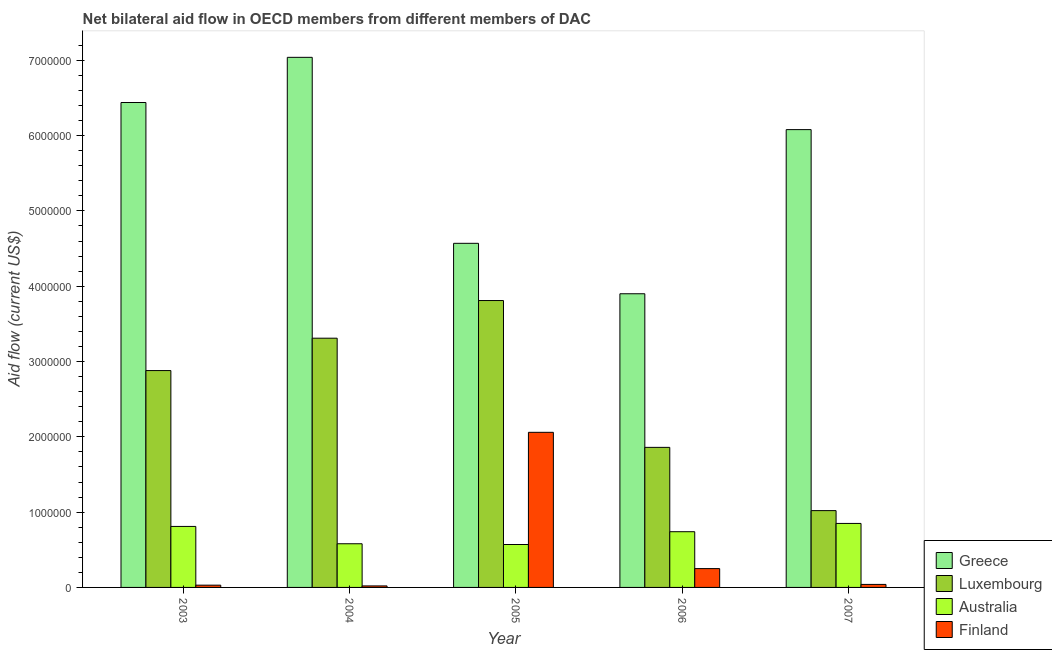How many different coloured bars are there?
Your response must be concise. 4. Are the number of bars on each tick of the X-axis equal?
Offer a very short reply. Yes. How many bars are there on the 1st tick from the right?
Give a very brief answer. 4. What is the amount of aid given by luxembourg in 2004?
Offer a very short reply. 3.31e+06. Across all years, what is the maximum amount of aid given by finland?
Make the answer very short. 2.06e+06. Across all years, what is the minimum amount of aid given by luxembourg?
Your answer should be very brief. 1.02e+06. In which year was the amount of aid given by australia minimum?
Your answer should be compact. 2005. What is the total amount of aid given by finland in the graph?
Ensure brevity in your answer.  2.40e+06. What is the difference between the amount of aid given by greece in 2003 and that in 2004?
Give a very brief answer. -6.00e+05. What is the difference between the amount of aid given by australia in 2005 and the amount of aid given by greece in 2007?
Keep it short and to the point. -2.80e+05. In how many years, is the amount of aid given by greece greater than 1400000 US$?
Offer a terse response. 5. What is the ratio of the amount of aid given by luxembourg in 2006 to that in 2007?
Provide a short and direct response. 1.82. Is the difference between the amount of aid given by finland in 2004 and 2006 greater than the difference between the amount of aid given by greece in 2004 and 2006?
Your answer should be very brief. No. What is the difference between the highest and the lowest amount of aid given by greece?
Your response must be concise. 3.14e+06. Is the sum of the amount of aid given by australia in 2003 and 2007 greater than the maximum amount of aid given by finland across all years?
Offer a very short reply. Yes. How many bars are there?
Provide a short and direct response. 20. How many years are there in the graph?
Keep it short and to the point. 5. Are the values on the major ticks of Y-axis written in scientific E-notation?
Offer a very short reply. No. Does the graph contain any zero values?
Give a very brief answer. No. Where does the legend appear in the graph?
Ensure brevity in your answer.  Bottom right. How many legend labels are there?
Your answer should be very brief. 4. What is the title of the graph?
Provide a succinct answer. Net bilateral aid flow in OECD members from different members of DAC. What is the label or title of the X-axis?
Your response must be concise. Year. What is the label or title of the Y-axis?
Your answer should be compact. Aid flow (current US$). What is the Aid flow (current US$) of Greece in 2003?
Your answer should be very brief. 6.44e+06. What is the Aid flow (current US$) in Luxembourg in 2003?
Give a very brief answer. 2.88e+06. What is the Aid flow (current US$) of Australia in 2003?
Your answer should be very brief. 8.10e+05. What is the Aid flow (current US$) in Finland in 2003?
Make the answer very short. 3.00e+04. What is the Aid flow (current US$) in Greece in 2004?
Your answer should be compact. 7.04e+06. What is the Aid flow (current US$) in Luxembourg in 2004?
Offer a very short reply. 3.31e+06. What is the Aid flow (current US$) in Australia in 2004?
Make the answer very short. 5.80e+05. What is the Aid flow (current US$) of Finland in 2004?
Your answer should be very brief. 2.00e+04. What is the Aid flow (current US$) in Greece in 2005?
Offer a terse response. 4.57e+06. What is the Aid flow (current US$) of Luxembourg in 2005?
Keep it short and to the point. 3.81e+06. What is the Aid flow (current US$) in Australia in 2005?
Offer a terse response. 5.70e+05. What is the Aid flow (current US$) in Finland in 2005?
Ensure brevity in your answer.  2.06e+06. What is the Aid flow (current US$) in Greece in 2006?
Your answer should be very brief. 3.90e+06. What is the Aid flow (current US$) in Luxembourg in 2006?
Offer a terse response. 1.86e+06. What is the Aid flow (current US$) in Australia in 2006?
Ensure brevity in your answer.  7.40e+05. What is the Aid flow (current US$) in Finland in 2006?
Provide a succinct answer. 2.50e+05. What is the Aid flow (current US$) of Greece in 2007?
Your response must be concise. 6.08e+06. What is the Aid flow (current US$) in Luxembourg in 2007?
Offer a very short reply. 1.02e+06. What is the Aid flow (current US$) in Australia in 2007?
Offer a terse response. 8.50e+05. Across all years, what is the maximum Aid flow (current US$) in Greece?
Your response must be concise. 7.04e+06. Across all years, what is the maximum Aid flow (current US$) of Luxembourg?
Your answer should be very brief. 3.81e+06. Across all years, what is the maximum Aid flow (current US$) of Australia?
Keep it short and to the point. 8.50e+05. Across all years, what is the maximum Aid flow (current US$) in Finland?
Your response must be concise. 2.06e+06. Across all years, what is the minimum Aid flow (current US$) of Greece?
Give a very brief answer. 3.90e+06. Across all years, what is the minimum Aid flow (current US$) of Luxembourg?
Offer a very short reply. 1.02e+06. Across all years, what is the minimum Aid flow (current US$) in Australia?
Your response must be concise. 5.70e+05. Across all years, what is the minimum Aid flow (current US$) in Finland?
Provide a succinct answer. 2.00e+04. What is the total Aid flow (current US$) of Greece in the graph?
Provide a succinct answer. 2.80e+07. What is the total Aid flow (current US$) in Luxembourg in the graph?
Give a very brief answer. 1.29e+07. What is the total Aid flow (current US$) of Australia in the graph?
Ensure brevity in your answer.  3.55e+06. What is the total Aid flow (current US$) of Finland in the graph?
Keep it short and to the point. 2.40e+06. What is the difference between the Aid flow (current US$) of Greece in 2003 and that in 2004?
Your answer should be compact. -6.00e+05. What is the difference between the Aid flow (current US$) of Luxembourg in 2003 and that in 2004?
Keep it short and to the point. -4.30e+05. What is the difference between the Aid flow (current US$) of Australia in 2003 and that in 2004?
Your answer should be compact. 2.30e+05. What is the difference between the Aid flow (current US$) in Greece in 2003 and that in 2005?
Provide a succinct answer. 1.87e+06. What is the difference between the Aid flow (current US$) of Luxembourg in 2003 and that in 2005?
Provide a short and direct response. -9.30e+05. What is the difference between the Aid flow (current US$) of Finland in 2003 and that in 2005?
Ensure brevity in your answer.  -2.03e+06. What is the difference between the Aid flow (current US$) in Greece in 2003 and that in 2006?
Offer a very short reply. 2.54e+06. What is the difference between the Aid flow (current US$) in Luxembourg in 2003 and that in 2006?
Offer a very short reply. 1.02e+06. What is the difference between the Aid flow (current US$) of Australia in 2003 and that in 2006?
Keep it short and to the point. 7.00e+04. What is the difference between the Aid flow (current US$) of Finland in 2003 and that in 2006?
Make the answer very short. -2.20e+05. What is the difference between the Aid flow (current US$) in Luxembourg in 2003 and that in 2007?
Give a very brief answer. 1.86e+06. What is the difference between the Aid flow (current US$) in Australia in 2003 and that in 2007?
Ensure brevity in your answer.  -4.00e+04. What is the difference between the Aid flow (current US$) of Finland in 2003 and that in 2007?
Provide a short and direct response. -10000. What is the difference between the Aid flow (current US$) in Greece in 2004 and that in 2005?
Your answer should be very brief. 2.47e+06. What is the difference between the Aid flow (current US$) in Luxembourg in 2004 and that in 2005?
Give a very brief answer. -5.00e+05. What is the difference between the Aid flow (current US$) in Finland in 2004 and that in 2005?
Your answer should be compact. -2.04e+06. What is the difference between the Aid flow (current US$) in Greece in 2004 and that in 2006?
Your answer should be compact. 3.14e+06. What is the difference between the Aid flow (current US$) of Luxembourg in 2004 and that in 2006?
Keep it short and to the point. 1.45e+06. What is the difference between the Aid flow (current US$) in Australia in 2004 and that in 2006?
Give a very brief answer. -1.60e+05. What is the difference between the Aid flow (current US$) in Greece in 2004 and that in 2007?
Offer a terse response. 9.60e+05. What is the difference between the Aid flow (current US$) of Luxembourg in 2004 and that in 2007?
Keep it short and to the point. 2.29e+06. What is the difference between the Aid flow (current US$) in Greece in 2005 and that in 2006?
Make the answer very short. 6.70e+05. What is the difference between the Aid flow (current US$) of Luxembourg in 2005 and that in 2006?
Offer a very short reply. 1.95e+06. What is the difference between the Aid flow (current US$) in Finland in 2005 and that in 2006?
Offer a very short reply. 1.81e+06. What is the difference between the Aid flow (current US$) of Greece in 2005 and that in 2007?
Ensure brevity in your answer.  -1.51e+06. What is the difference between the Aid flow (current US$) in Luxembourg in 2005 and that in 2007?
Your answer should be compact. 2.79e+06. What is the difference between the Aid flow (current US$) of Australia in 2005 and that in 2007?
Your answer should be compact. -2.80e+05. What is the difference between the Aid flow (current US$) in Finland in 2005 and that in 2007?
Make the answer very short. 2.02e+06. What is the difference between the Aid flow (current US$) of Greece in 2006 and that in 2007?
Provide a succinct answer. -2.18e+06. What is the difference between the Aid flow (current US$) in Luxembourg in 2006 and that in 2007?
Your answer should be very brief. 8.40e+05. What is the difference between the Aid flow (current US$) of Greece in 2003 and the Aid flow (current US$) of Luxembourg in 2004?
Offer a terse response. 3.13e+06. What is the difference between the Aid flow (current US$) in Greece in 2003 and the Aid flow (current US$) in Australia in 2004?
Provide a short and direct response. 5.86e+06. What is the difference between the Aid flow (current US$) of Greece in 2003 and the Aid flow (current US$) of Finland in 2004?
Provide a short and direct response. 6.42e+06. What is the difference between the Aid flow (current US$) of Luxembourg in 2003 and the Aid flow (current US$) of Australia in 2004?
Keep it short and to the point. 2.30e+06. What is the difference between the Aid flow (current US$) of Luxembourg in 2003 and the Aid flow (current US$) of Finland in 2004?
Ensure brevity in your answer.  2.86e+06. What is the difference between the Aid flow (current US$) in Australia in 2003 and the Aid flow (current US$) in Finland in 2004?
Your answer should be compact. 7.90e+05. What is the difference between the Aid flow (current US$) of Greece in 2003 and the Aid flow (current US$) of Luxembourg in 2005?
Your answer should be compact. 2.63e+06. What is the difference between the Aid flow (current US$) of Greece in 2003 and the Aid flow (current US$) of Australia in 2005?
Provide a short and direct response. 5.87e+06. What is the difference between the Aid flow (current US$) of Greece in 2003 and the Aid flow (current US$) of Finland in 2005?
Offer a very short reply. 4.38e+06. What is the difference between the Aid flow (current US$) in Luxembourg in 2003 and the Aid flow (current US$) in Australia in 2005?
Keep it short and to the point. 2.31e+06. What is the difference between the Aid flow (current US$) of Luxembourg in 2003 and the Aid flow (current US$) of Finland in 2005?
Keep it short and to the point. 8.20e+05. What is the difference between the Aid flow (current US$) of Australia in 2003 and the Aid flow (current US$) of Finland in 2005?
Your response must be concise. -1.25e+06. What is the difference between the Aid flow (current US$) of Greece in 2003 and the Aid flow (current US$) of Luxembourg in 2006?
Make the answer very short. 4.58e+06. What is the difference between the Aid flow (current US$) in Greece in 2003 and the Aid flow (current US$) in Australia in 2006?
Make the answer very short. 5.70e+06. What is the difference between the Aid flow (current US$) of Greece in 2003 and the Aid flow (current US$) of Finland in 2006?
Give a very brief answer. 6.19e+06. What is the difference between the Aid flow (current US$) of Luxembourg in 2003 and the Aid flow (current US$) of Australia in 2006?
Your answer should be compact. 2.14e+06. What is the difference between the Aid flow (current US$) of Luxembourg in 2003 and the Aid flow (current US$) of Finland in 2006?
Offer a very short reply. 2.63e+06. What is the difference between the Aid flow (current US$) in Australia in 2003 and the Aid flow (current US$) in Finland in 2006?
Ensure brevity in your answer.  5.60e+05. What is the difference between the Aid flow (current US$) of Greece in 2003 and the Aid flow (current US$) of Luxembourg in 2007?
Provide a succinct answer. 5.42e+06. What is the difference between the Aid flow (current US$) of Greece in 2003 and the Aid flow (current US$) of Australia in 2007?
Your response must be concise. 5.59e+06. What is the difference between the Aid flow (current US$) of Greece in 2003 and the Aid flow (current US$) of Finland in 2007?
Offer a terse response. 6.40e+06. What is the difference between the Aid flow (current US$) of Luxembourg in 2003 and the Aid flow (current US$) of Australia in 2007?
Your answer should be very brief. 2.03e+06. What is the difference between the Aid flow (current US$) of Luxembourg in 2003 and the Aid flow (current US$) of Finland in 2007?
Your answer should be compact. 2.84e+06. What is the difference between the Aid flow (current US$) in Australia in 2003 and the Aid flow (current US$) in Finland in 2007?
Offer a very short reply. 7.70e+05. What is the difference between the Aid flow (current US$) of Greece in 2004 and the Aid flow (current US$) of Luxembourg in 2005?
Make the answer very short. 3.23e+06. What is the difference between the Aid flow (current US$) of Greece in 2004 and the Aid flow (current US$) of Australia in 2005?
Offer a very short reply. 6.47e+06. What is the difference between the Aid flow (current US$) of Greece in 2004 and the Aid flow (current US$) of Finland in 2005?
Offer a very short reply. 4.98e+06. What is the difference between the Aid flow (current US$) of Luxembourg in 2004 and the Aid flow (current US$) of Australia in 2005?
Provide a succinct answer. 2.74e+06. What is the difference between the Aid flow (current US$) of Luxembourg in 2004 and the Aid flow (current US$) of Finland in 2005?
Keep it short and to the point. 1.25e+06. What is the difference between the Aid flow (current US$) in Australia in 2004 and the Aid flow (current US$) in Finland in 2005?
Keep it short and to the point. -1.48e+06. What is the difference between the Aid flow (current US$) in Greece in 2004 and the Aid flow (current US$) in Luxembourg in 2006?
Offer a terse response. 5.18e+06. What is the difference between the Aid flow (current US$) in Greece in 2004 and the Aid flow (current US$) in Australia in 2006?
Provide a succinct answer. 6.30e+06. What is the difference between the Aid flow (current US$) in Greece in 2004 and the Aid flow (current US$) in Finland in 2006?
Make the answer very short. 6.79e+06. What is the difference between the Aid flow (current US$) of Luxembourg in 2004 and the Aid flow (current US$) of Australia in 2006?
Your answer should be very brief. 2.57e+06. What is the difference between the Aid flow (current US$) of Luxembourg in 2004 and the Aid flow (current US$) of Finland in 2006?
Ensure brevity in your answer.  3.06e+06. What is the difference between the Aid flow (current US$) in Greece in 2004 and the Aid flow (current US$) in Luxembourg in 2007?
Your answer should be compact. 6.02e+06. What is the difference between the Aid flow (current US$) in Greece in 2004 and the Aid flow (current US$) in Australia in 2007?
Provide a succinct answer. 6.19e+06. What is the difference between the Aid flow (current US$) in Luxembourg in 2004 and the Aid flow (current US$) in Australia in 2007?
Provide a short and direct response. 2.46e+06. What is the difference between the Aid flow (current US$) of Luxembourg in 2004 and the Aid flow (current US$) of Finland in 2007?
Provide a succinct answer. 3.27e+06. What is the difference between the Aid flow (current US$) in Australia in 2004 and the Aid flow (current US$) in Finland in 2007?
Offer a very short reply. 5.40e+05. What is the difference between the Aid flow (current US$) of Greece in 2005 and the Aid flow (current US$) of Luxembourg in 2006?
Provide a succinct answer. 2.71e+06. What is the difference between the Aid flow (current US$) of Greece in 2005 and the Aid flow (current US$) of Australia in 2006?
Your answer should be very brief. 3.83e+06. What is the difference between the Aid flow (current US$) in Greece in 2005 and the Aid flow (current US$) in Finland in 2006?
Offer a terse response. 4.32e+06. What is the difference between the Aid flow (current US$) in Luxembourg in 2005 and the Aid flow (current US$) in Australia in 2006?
Offer a terse response. 3.07e+06. What is the difference between the Aid flow (current US$) of Luxembourg in 2005 and the Aid flow (current US$) of Finland in 2006?
Provide a succinct answer. 3.56e+06. What is the difference between the Aid flow (current US$) in Australia in 2005 and the Aid flow (current US$) in Finland in 2006?
Provide a short and direct response. 3.20e+05. What is the difference between the Aid flow (current US$) of Greece in 2005 and the Aid flow (current US$) of Luxembourg in 2007?
Give a very brief answer. 3.55e+06. What is the difference between the Aid flow (current US$) in Greece in 2005 and the Aid flow (current US$) in Australia in 2007?
Offer a very short reply. 3.72e+06. What is the difference between the Aid flow (current US$) of Greece in 2005 and the Aid flow (current US$) of Finland in 2007?
Ensure brevity in your answer.  4.53e+06. What is the difference between the Aid flow (current US$) in Luxembourg in 2005 and the Aid flow (current US$) in Australia in 2007?
Your answer should be compact. 2.96e+06. What is the difference between the Aid flow (current US$) of Luxembourg in 2005 and the Aid flow (current US$) of Finland in 2007?
Ensure brevity in your answer.  3.77e+06. What is the difference between the Aid flow (current US$) of Australia in 2005 and the Aid flow (current US$) of Finland in 2007?
Provide a succinct answer. 5.30e+05. What is the difference between the Aid flow (current US$) of Greece in 2006 and the Aid flow (current US$) of Luxembourg in 2007?
Your answer should be compact. 2.88e+06. What is the difference between the Aid flow (current US$) of Greece in 2006 and the Aid flow (current US$) of Australia in 2007?
Make the answer very short. 3.05e+06. What is the difference between the Aid flow (current US$) of Greece in 2006 and the Aid flow (current US$) of Finland in 2007?
Keep it short and to the point. 3.86e+06. What is the difference between the Aid flow (current US$) of Luxembourg in 2006 and the Aid flow (current US$) of Australia in 2007?
Your response must be concise. 1.01e+06. What is the difference between the Aid flow (current US$) in Luxembourg in 2006 and the Aid flow (current US$) in Finland in 2007?
Your answer should be compact. 1.82e+06. What is the average Aid flow (current US$) of Greece per year?
Give a very brief answer. 5.61e+06. What is the average Aid flow (current US$) of Luxembourg per year?
Make the answer very short. 2.58e+06. What is the average Aid flow (current US$) in Australia per year?
Your answer should be very brief. 7.10e+05. What is the average Aid flow (current US$) in Finland per year?
Give a very brief answer. 4.80e+05. In the year 2003, what is the difference between the Aid flow (current US$) in Greece and Aid flow (current US$) in Luxembourg?
Your answer should be very brief. 3.56e+06. In the year 2003, what is the difference between the Aid flow (current US$) of Greece and Aid flow (current US$) of Australia?
Your response must be concise. 5.63e+06. In the year 2003, what is the difference between the Aid flow (current US$) of Greece and Aid flow (current US$) of Finland?
Provide a succinct answer. 6.41e+06. In the year 2003, what is the difference between the Aid flow (current US$) in Luxembourg and Aid flow (current US$) in Australia?
Your answer should be very brief. 2.07e+06. In the year 2003, what is the difference between the Aid flow (current US$) of Luxembourg and Aid flow (current US$) of Finland?
Your answer should be compact. 2.85e+06. In the year 2003, what is the difference between the Aid flow (current US$) of Australia and Aid flow (current US$) of Finland?
Keep it short and to the point. 7.80e+05. In the year 2004, what is the difference between the Aid flow (current US$) in Greece and Aid flow (current US$) in Luxembourg?
Offer a terse response. 3.73e+06. In the year 2004, what is the difference between the Aid flow (current US$) of Greece and Aid flow (current US$) of Australia?
Offer a terse response. 6.46e+06. In the year 2004, what is the difference between the Aid flow (current US$) in Greece and Aid flow (current US$) in Finland?
Make the answer very short. 7.02e+06. In the year 2004, what is the difference between the Aid flow (current US$) of Luxembourg and Aid flow (current US$) of Australia?
Provide a short and direct response. 2.73e+06. In the year 2004, what is the difference between the Aid flow (current US$) in Luxembourg and Aid flow (current US$) in Finland?
Provide a short and direct response. 3.29e+06. In the year 2004, what is the difference between the Aid flow (current US$) of Australia and Aid flow (current US$) of Finland?
Provide a short and direct response. 5.60e+05. In the year 2005, what is the difference between the Aid flow (current US$) in Greece and Aid flow (current US$) in Luxembourg?
Offer a very short reply. 7.60e+05. In the year 2005, what is the difference between the Aid flow (current US$) in Greece and Aid flow (current US$) in Australia?
Keep it short and to the point. 4.00e+06. In the year 2005, what is the difference between the Aid flow (current US$) in Greece and Aid flow (current US$) in Finland?
Your answer should be very brief. 2.51e+06. In the year 2005, what is the difference between the Aid flow (current US$) of Luxembourg and Aid flow (current US$) of Australia?
Keep it short and to the point. 3.24e+06. In the year 2005, what is the difference between the Aid flow (current US$) of Luxembourg and Aid flow (current US$) of Finland?
Offer a terse response. 1.75e+06. In the year 2005, what is the difference between the Aid flow (current US$) in Australia and Aid flow (current US$) in Finland?
Ensure brevity in your answer.  -1.49e+06. In the year 2006, what is the difference between the Aid flow (current US$) in Greece and Aid flow (current US$) in Luxembourg?
Your response must be concise. 2.04e+06. In the year 2006, what is the difference between the Aid flow (current US$) of Greece and Aid flow (current US$) of Australia?
Give a very brief answer. 3.16e+06. In the year 2006, what is the difference between the Aid flow (current US$) in Greece and Aid flow (current US$) in Finland?
Your answer should be very brief. 3.65e+06. In the year 2006, what is the difference between the Aid flow (current US$) in Luxembourg and Aid flow (current US$) in Australia?
Give a very brief answer. 1.12e+06. In the year 2006, what is the difference between the Aid flow (current US$) of Luxembourg and Aid flow (current US$) of Finland?
Make the answer very short. 1.61e+06. In the year 2006, what is the difference between the Aid flow (current US$) in Australia and Aid flow (current US$) in Finland?
Offer a very short reply. 4.90e+05. In the year 2007, what is the difference between the Aid flow (current US$) in Greece and Aid flow (current US$) in Luxembourg?
Your answer should be compact. 5.06e+06. In the year 2007, what is the difference between the Aid flow (current US$) of Greece and Aid flow (current US$) of Australia?
Keep it short and to the point. 5.23e+06. In the year 2007, what is the difference between the Aid flow (current US$) in Greece and Aid flow (current US$) in Finland?
Provide a short and direct response. 6.04e+06. In the year 2007, what is the difference between the Aid flow (current US$) in Luxembourg and Aid flow (current US$) in Australia?
Your answer should be very brief. 1.70e+05. In the year 2007, what is the difference between the Aid flow (current US$) of Luxembourg and Aid flow (current US$) of Finland?
Make the answer very short. 9.80e+05. In the year 2007, what is the difference between the Aid flow (current US$) of Australia and Aid flow (current US$) of Finland?
Your answer should be very brief. 8.10e+05. What is the ratio of the Aid flow (current US$) of Greece in 2003 to that in 2004?
Offer a terse response. 0.91. What is the ratio of the Aid flow (current US$) in Luxembourg in 2003 to that in 2004?
Offer a very short reply. 0.87. What is the ratio of the Aid flow (current US$) in Australia in 2003 to that in 2004?
Offer a very short reply. 1.4. What is the ratio of the Aid flow (current US$) of Greece in 2003 to that in 2005?
Ensure brevity in your answer.  1.41. What is the ratio of the Aid flow (current US$) of Luxembourg in 2003 to that in 2005?
Ensure brevity in your answer.  0.76. What is the ratio of the Aid flow (current US$) in Australia in 2003 to that in 2005?
Your response must be concise. 1.42. What is the ratio of the Aid flow (current US$) in Finland in 2003 to that in 2005?
Offer a terse response. 0.01. What is the ratio of the Aid flow (current US$) in Greece in 2003 to that in 2006?
Your answer should be compact. 1.65. What is the ratio of the Aid flow (current US$) in Luxembourg in 2003 to that in 2006?
Give a very brief answer. 1.55. What is the ratio of the Aid flow (current US$) of Australia in 2003 to that in 2006?
Ensure brevity in your answer.  1.09. What is the ratio of the Aid flow (current US$) of Finland in 2003 to that in 2006?
Offer a terse response. 0.12. What is the ratio of the Aid flow (current US$) of Greece in 2003 to that in 2007?
Your answer should be very brief. 1.06. What is the ratio of the Aid flow (current US$) in Luxembourg in 2003 to that in 2007?
Make the answer very short. 2.82. What is the ratio of the Aid flow (current US$) of Australia in 2003 to that in 2007?
Your response must be concise. 0.95. What is the ratio of the Aid flow (current US$) of Greece in 2004 to that in 2005?
Your answer should be compact. 1.54. What is the ratio of the Aid flow (current US$) of Luxembourg in 2004 to that in 2005?
Offer a terse response. 0.87. What is the ratio of the Aid flow (current US$) in Australia in 2004 to that in 2005?
Provide a short and direct response. 1.02. What is the ratio of the Aid flow (current US$) of Finland in 2004 to that in 2005?
Provide a short and direct response. 0.01. What is the ratio of the Aid flow (current US$) of Greece in 2004 to that in 2006?
Your answer should be very brief. 1.81. What is the ratio of the Aid flow (current US$) in Luxembourg in 2004 to that in 2006?
Offer a very short reply. 1.78. What is the ratio of the Aid flow (current US$) in Australia in 2004 to that in 2006?
Offer a very short reply. 0.78. What is the ratio of the Aid flow (current US$) of Greece in 2004 to that in 2007?
Your response must be concise. 1.16. What is the ratio of the Aid flow (current US$) in Luxembourg in 2004 to that in 2007?
Keep it short and to the point. 3.25. What is the ratio of the Aid flow (current US$) of Australia in 2004 to that in 2007?
Ensure brevity in your answer.  0.68. What is the ratio of the Aid flow (current US$) in Greece in 2005 to that in 2006?
Your response must be concise. 1.17. What is the ratio of the Aid flow (current US$) of Luxembourg in 2005 to that in 2006?
Offer a terse response. 2.05. What is the ratio of the Aid flow (current US$) of Australia in 2005 to that in 2006?
Your answer should be compact. 0.77. What is the ratio of the Aid flow (current US$) in Finland in 2005 to that in 2006?
Make the answer very short. 8.24. What is the ratio of the Aid flow (current US$) in Greece in 2005 to that in 2007?
Provide a succinct answer. 0.75. What is the ratio of the Aid flow (current US$) in Luxembourg in 2005 to that in 2007?
Keep it short and to the point. 3.74. What is the ratio of the Aid flow (current US$) in Australia in 2005 to that in 2007?
Ensure brevity in your answer.  0.67. What is the ratio of the Aid flow (current US$) in Finland in 2005 to that in 2007?
Offer a very short reply. 51.5. What is the ratio of the Aid flow (current US$) in Greece in 2006 to that in 2007?
Make the answer very short. 0.64. What is the ratio of the Aid flow (current US$) in Luxembourg in 2006 to that in 2007?
Your answer should be very brief. 1.82. What is the ratio of the Aid flow (current US$) in Australia in 2006 to that in 2007?
Offer a terse response. 0.87. What is the ratio of the Aid flow (current US$) of Finland in 2006 to that in 2007?
Ensure brevity in your answer.  6.25. What is the difference between the highest and the second highest Aid flow (current US$) of Luxembourg?
Provide a succinct answer. 5.00e+05. What is the difference between the highest and the second highest Aid flow (current US$) in Finland?
Make the answer very short. 1.81e+06. What is the difference between the highest and the lowest Aid flow (current US$) in Greece?
Keep it short and to the point. 3.14e+06. What is the difference between the highest and the lowest Aid flow (current US$) of Luxembourg?
Your answer should be compact. 2.79e+06. What is the difference between the highest and the lowest Aid flow (current US$) of Australia?
Offer a terse response. 2.80e+05. What is the difference between the highest and the lowest Aid flow (current US$) of Finland?
Keep it short and to the point. 2.04e+06. 